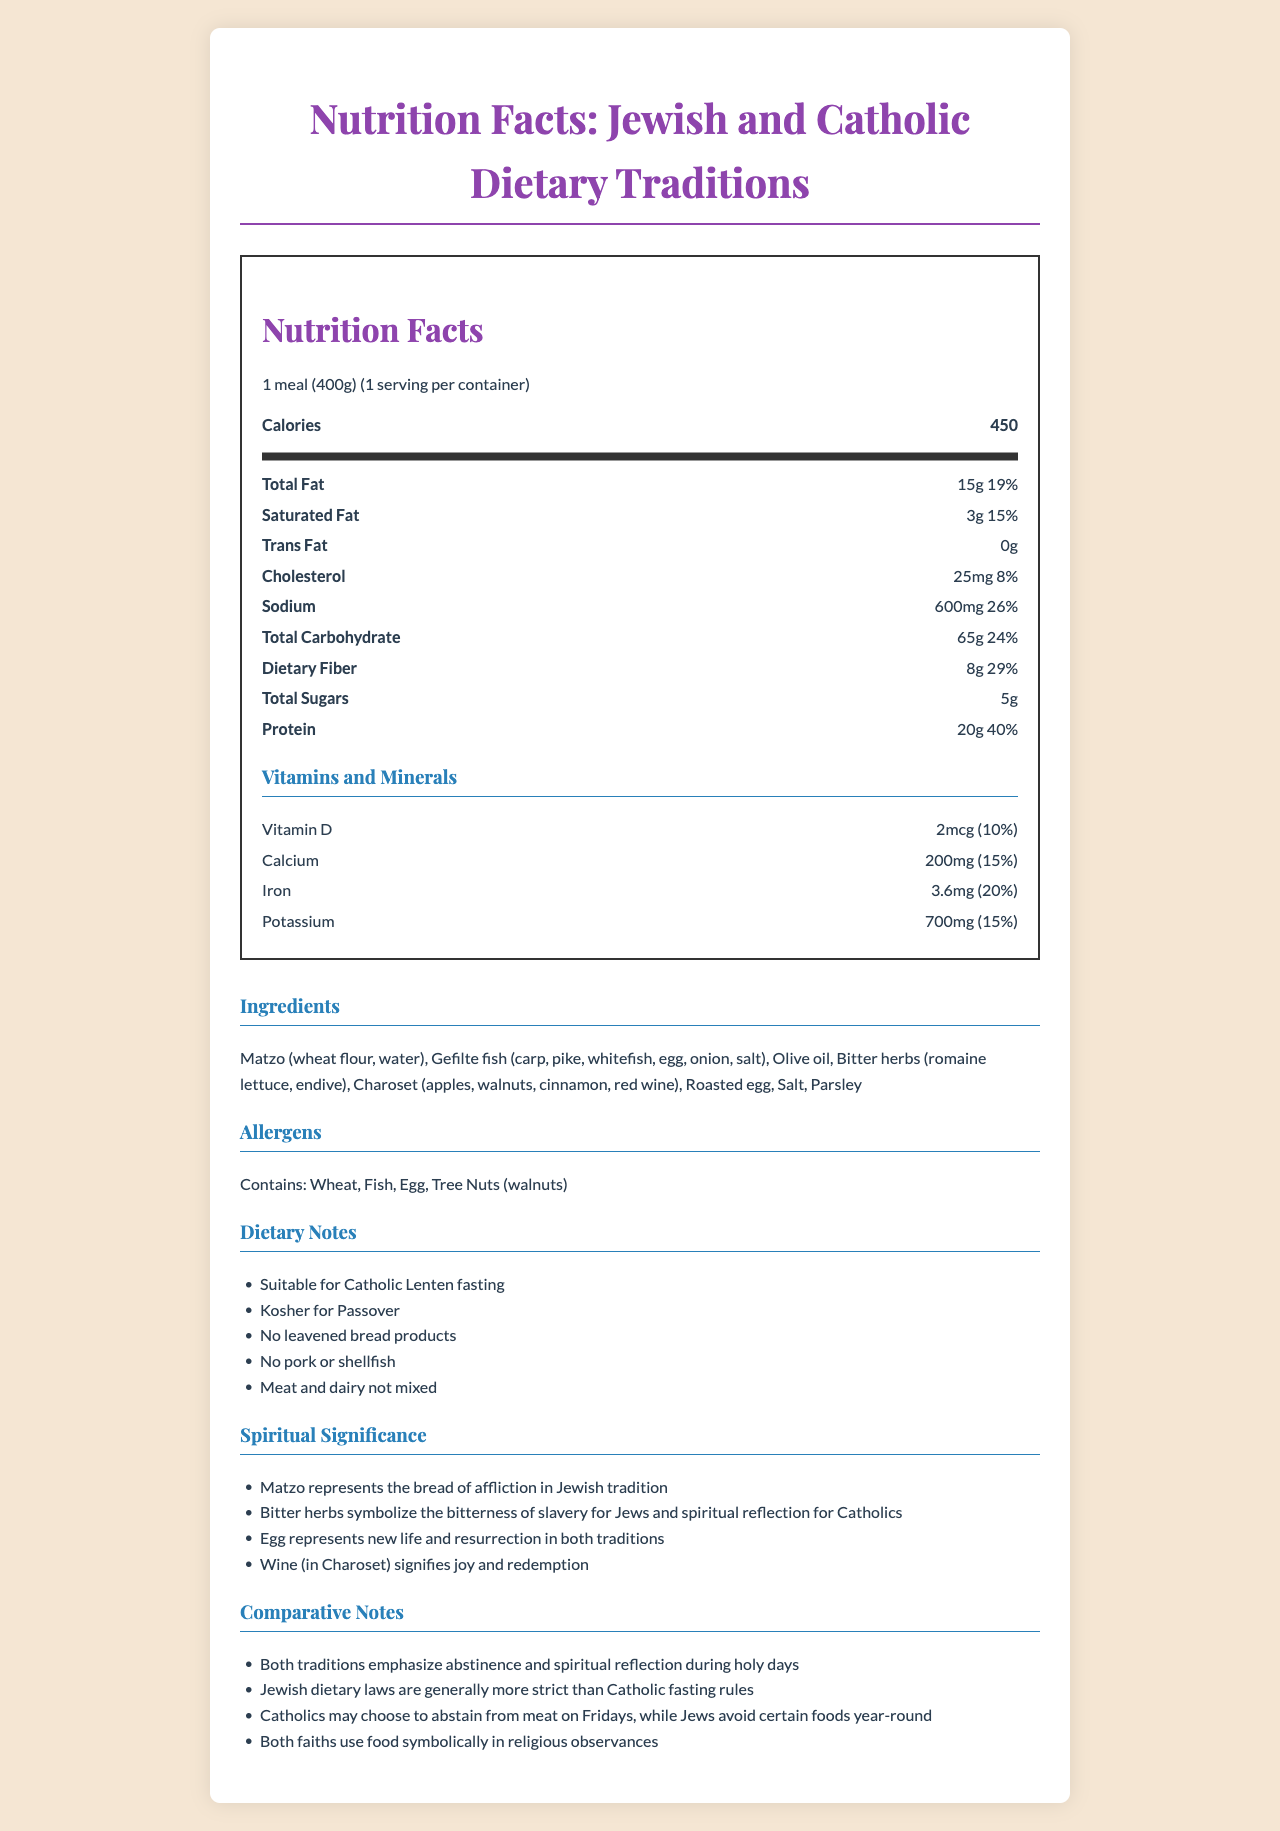what is the serving size? The serving size is clearly stated at the beginning of the Nutrition Facts.
Answer: 1 meal (400g) how many calories are there per serving? The document lists 450 calories per serving in the Nutrition Facts section.
Answer: 450 what is the amount of Total Fat per serving? The amount of Total Fat per serving is shown as 15g in the nutrition label.
Answer: 15g what is the daily value percentage for Sodium? The daily value percentage for Sodium is listed as 26% in the nutrition information.
Answer: 26% what ingredients are in the meal? The ingredients are provided in a list under the Ingredients section of the document.
Answer: Matzo, Gefilte fish, Olive oil, Bitter herbs, Charoset, Roasted egg, Salt, Parsley which nutrient has the highest daily value percentage? A. Total Fat B. Dietary Fiber C. Protein D. Cholesterol Protein has the highest daily value percentage at 40% as listed in the Nutrition Facts.
Answer: C. Protein which allergen is NOT listed in the document? A. Wheat B. Fish C. Tree Nuts D. Soy The allergens listed are Wheat, Fish, Egg, and Tree Nuts, but not Soy.
Answer: D. Soy is the meal suitable for Catholic Lenten fasting? The dietary notes indicate that the meal is suitable for Catholic Lenten fasting.
Answer: Yes does the document mention if the meal contains any pork or shellfish? The dietary notes specifically state that there are no leavened bread products and no pork or shellfish.
Answer: No what symbolic meaning does the bitter herbs have in both Jewish and Catholic traditions? The Spiritual Significance section notes that Bitter herbs symbolize the bitterness of slavery for Jews and spiritual reflection for Catholics.
Answer: The bitterness of slavery for Jews and spiritual reflection for Catholics how do Jewish dietary laws compare to Catholic fasting rules according to the document? The Comparative Notes section mentions that Jewish dietary laws are more strict than Catholic fasting rules.
Answer: Jewish dietary laws are generally more strict than Catholic fasting rules what is the main idea of the document? The document aims to provide comprehensive information on the dietary and spiritual significance of a meal suitable for both Jewish and Catholic traditions during their respective holy days.
Answer: The document provides detailed nutritional information about a meal, compares Jewish and Catholic dietary practices during holy days, lists ingredients, allergens, and their spiritual significance. what percentage of the daily value does Total Carbohydrate account for? The Total Carbohydrate accounts for 24% of the daily value, as listed in the Nutrition Facts.
Answer: 24% why is meat and dairy not mixed in this meal? The dietary notes mention that meat and dairy are not mixed, which aligns with Jewish dietary laws.
Answer: Jewish dietary laws prohibit mixing meat and dairy products. is the document's meal Kosher for Passover? The dietary notes specify that the meal is Kosher for Passover.
Answer: Yes what is the spiritual significance of the roasted egg in both traditions? The Spiritual Significance section states that the egg represents new life and resurrection in both traditions.
Answer: Represents new life and resurrection what is the percentage of the daily value for Iron in the meal? The document lists Iron at 20% of the daily value in the Vitamins and Minerals section.
Answer: 20% is it mentioned if the meal has any Vitamin C content? The document does not list Vitamin C in the Vitamins and Minerals section.
Answer: No, it is not mentioned who is the intended audience for this document? The document does not specify an intended audience directly.
Answer: Cannot be determined 